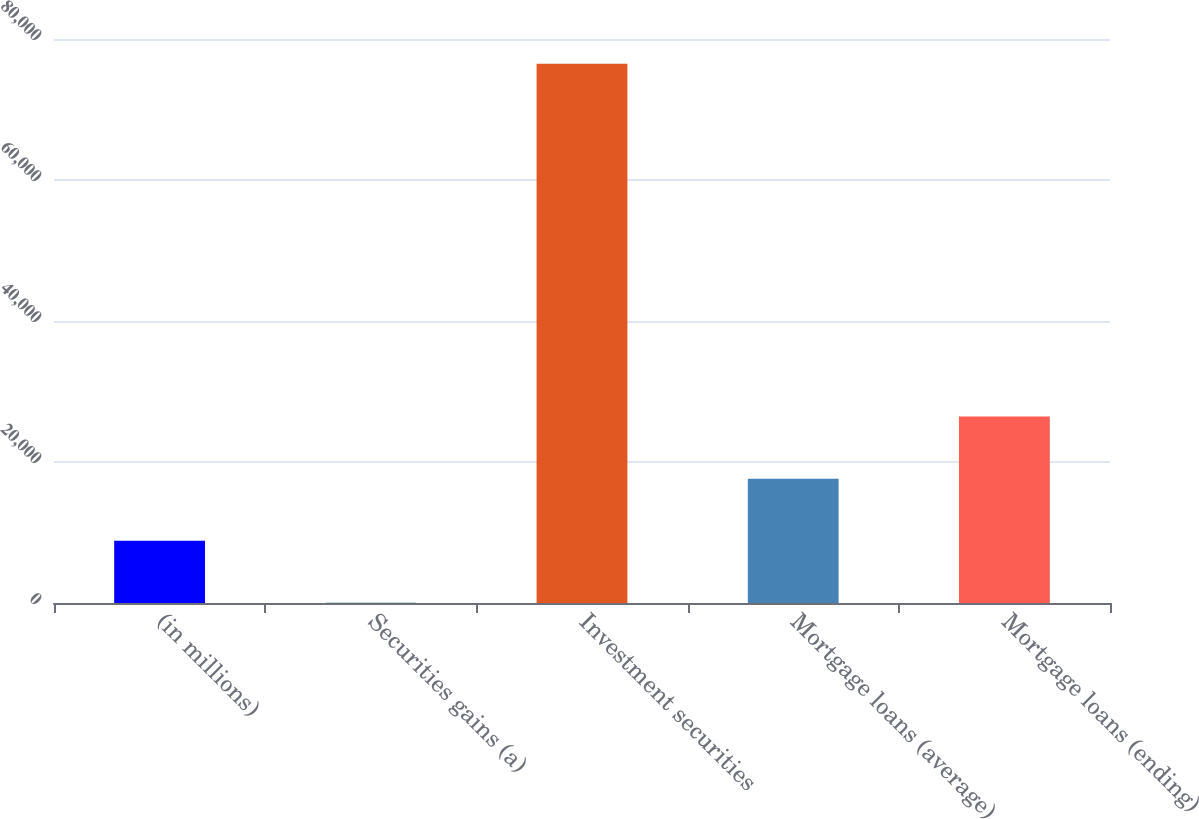<chart> <loc_0><loc_0><loc_500><loc_500><bar_chart><fcel>(in millions)<fcel>Securities gains (a)<fcel>Investment securities<fcel>Mortgage loans (average)<fcel>Mortgage loans (ending)<nl><fcel>8837<fcel>37<fcel>76480<fcel>17637<fcel>26437<nl></chart> 